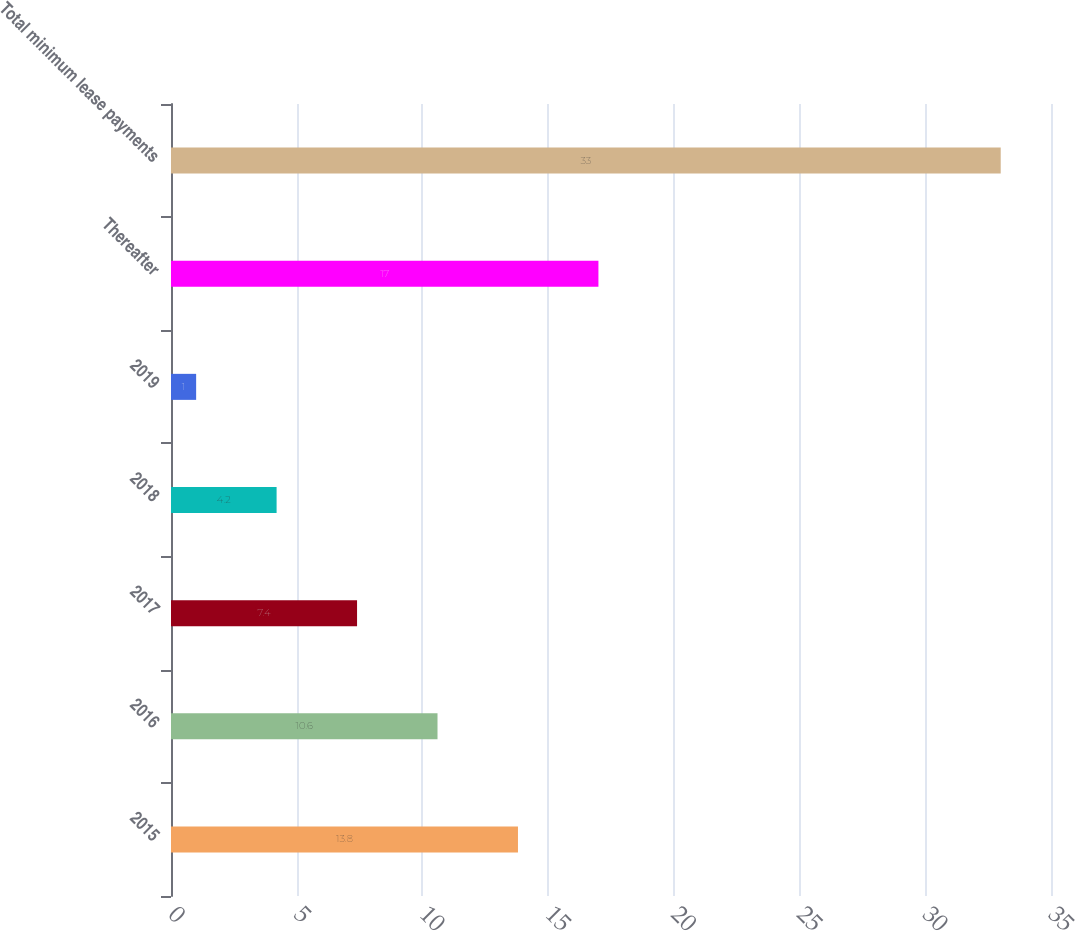Convert chart. <chart><loc_0><loc_0><loc_500><loc_500><bar_chart><fcel>2015<fcel>2016<fcel>2017<fcel>2018<fcel>2019<fcel>Thereafter<fcel>Total minimum lease payments<nl><fcel>13.8<fcel>10.6<fcel>7.4<fcel>4.2<fcel>1<fcel>17<fcel>33<nl></chart> 